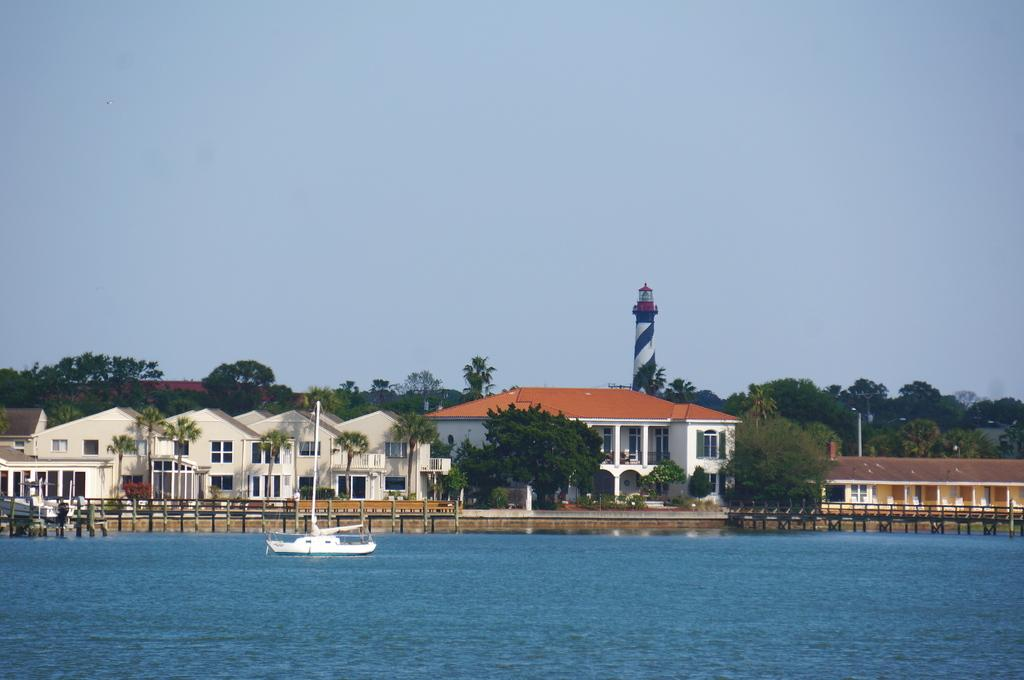What type of structures can be seen in the image? There are buildings and a tower in the image. What is a feature of one of the buildings? There is a window in the image. What type of vegetation is present in the image? There are trees in the image. What is the boat's location in the image? The boat is in the water visible in the image. What is the color of the sky in the image? The sky is visible in the image and has a blue color. What tax is being discussed in the image? There is no discussion of taxes in the image; it features buildings, a tower, trees, a boat, water, and a blue sky. What request is being made in the image? There is no request being made in the image; it is a static representation of the mentioned elements. 